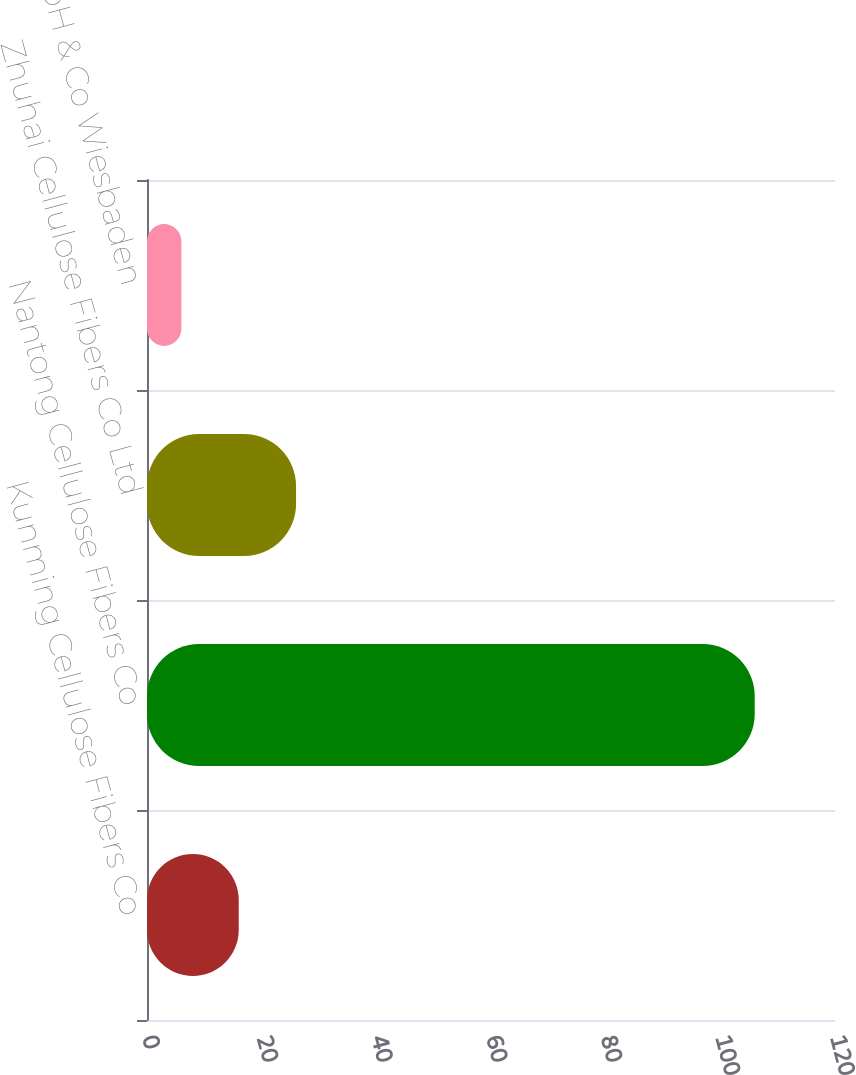Convert chart. <chart><loc_0><loc_0><loc_500><loc_500><bar_chart><fcel>Kunming Cellulose Fibers Co<fcel>Nantong Cellulose Fibers Co<fcel>Zhuhai Cellulose Fibers Co Ltd<fcel>InfraServ GmbH & Co Wiesbaden<nl><fcel>16<fcel>106<fcel>26<fcel>6<nl></chart> 